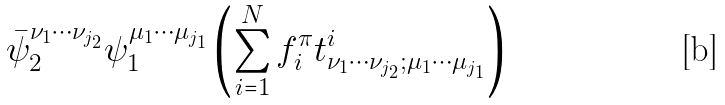Convert formula to latex. <formula><loc_0><loc_0><loc_500><loc_500>\bar { \psi } _ { 2 } ^ { \nu _ { 1 } \cdots \nu _ { j _ { 2 } } } \psi _ { 1 } ^ { \mu _ { 1 } \cdots \mu _ { j _ { 1 } } } \left ( \sum _ { i = 1 } ^ { N } f _ { i } ^ { \pi } t ^ { i } _ { \nu _ { 1 } \cdots \nu _ { j _ { 2 } } ; \mu _ { 1 } \cdots \mu _ { j _ { 1 } } } \right )</formula> 